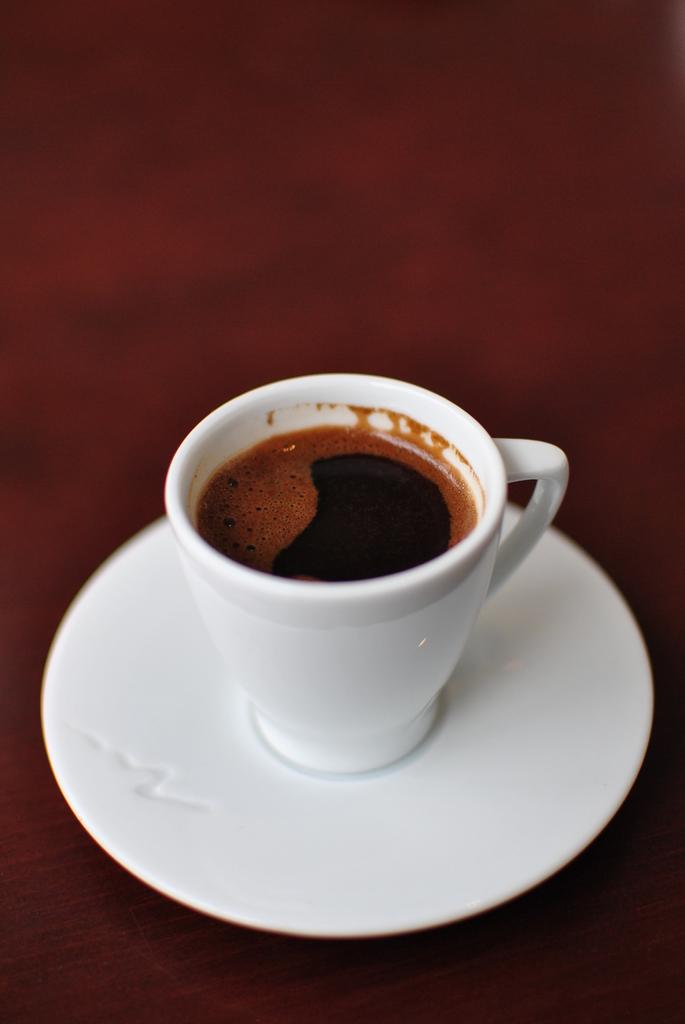What object in the image is white and contains liquid? There is a white cup in the image that contains liquid. What is the white cup placed on? The white cup is on a white plate. What color is the background of the image? The background of the image is maroon in color. What type of flower is growing on the coach in the image? There is no coach or flower present in the image. 